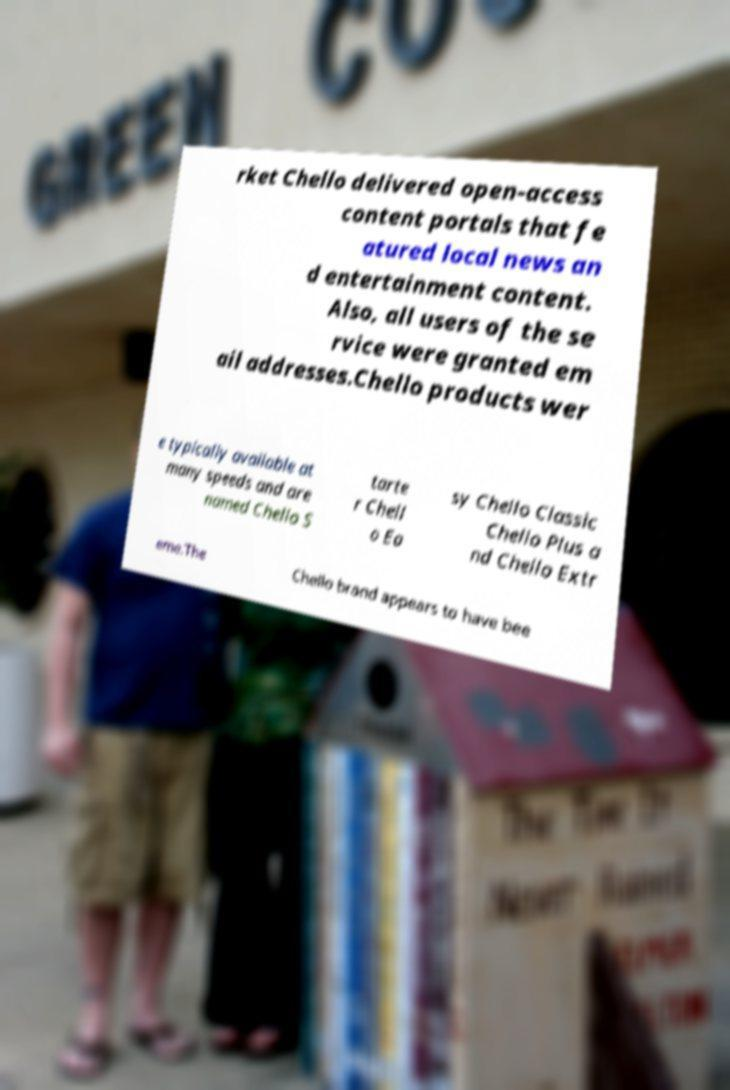Please identify and transcribe the text found in this image. rket Chello delivered open-access content portals that fe atured local news an d entertainment content. Also, all users of the se rvice were granted em ail addresses.Chello products wer e typically available at many speeds and are named Chello S tarte r Chell o Ea sy Chello Classic Chello Plus a nd Chello Extr eme.The Chello brand appears to have bee 